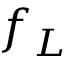<formula> <loc_0><loc_0><loc_500><loc_500>f _ { L }</formula> 